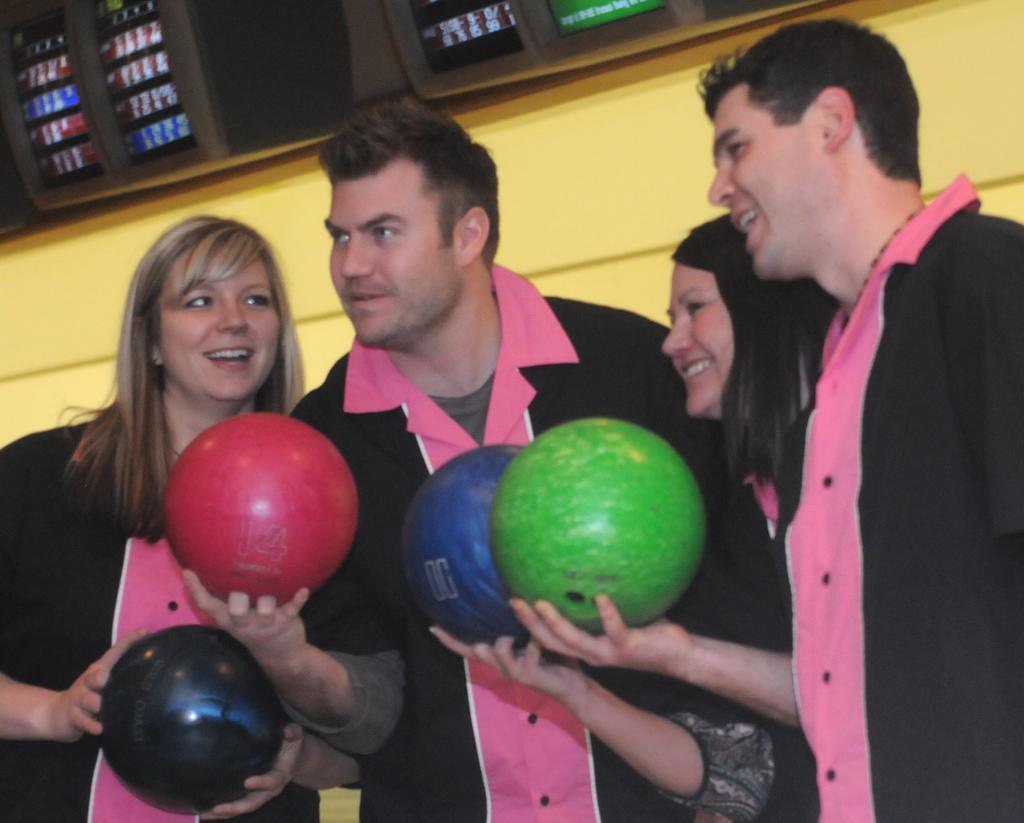Describe this image in one or two sentences. In the background we can see the screens and the wall. In this picture we can see the people are holding balls in their hands. 